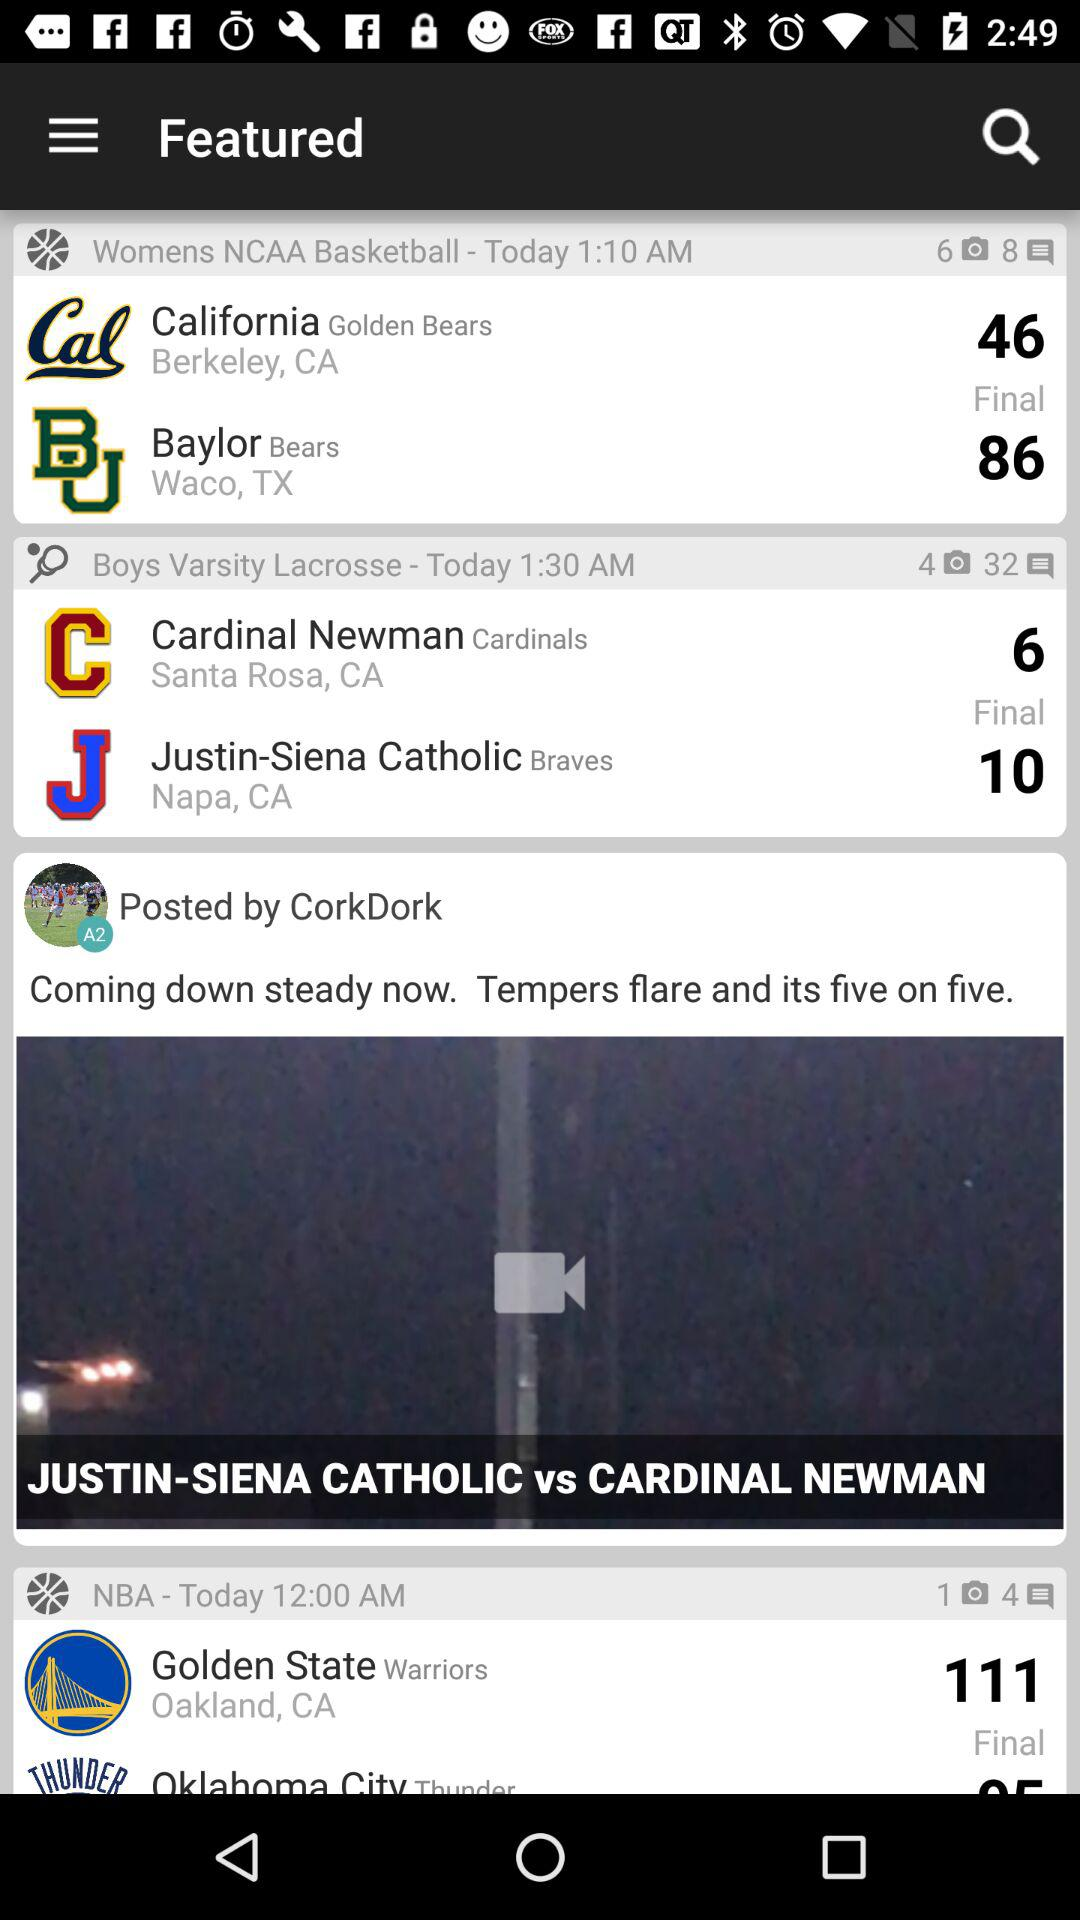How many comments are on "Boys Varsity Lacrosse"? There are 32 comments on "Boys Varsity Lacrosse". 